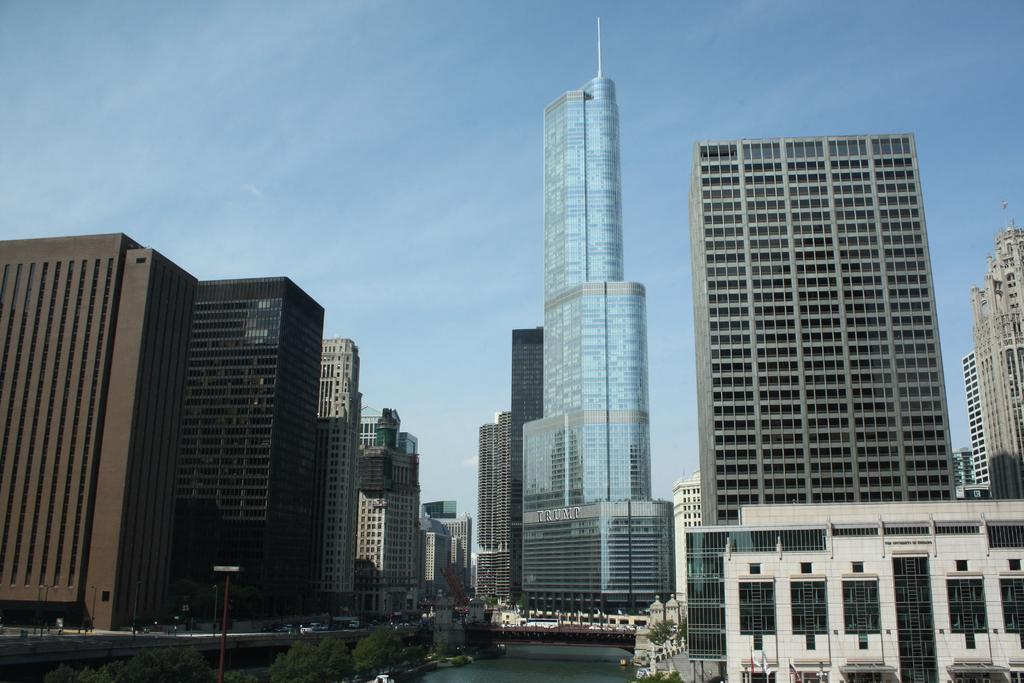What type of structures can be seen in the image? There are buildings in the image. What natural element is visible in the image? There is water visible in the image. What type of vegetation is present in the image? There are trees in the image. What man-made feature is in the foreground of the image? There is a road in the foreground of the image. What can be seen in the background of the image? The sky is visible in the background of the image. What type of creature is making a discovery in the image? There is no creature present in the image, nor is there any indication of a discovery being made. 